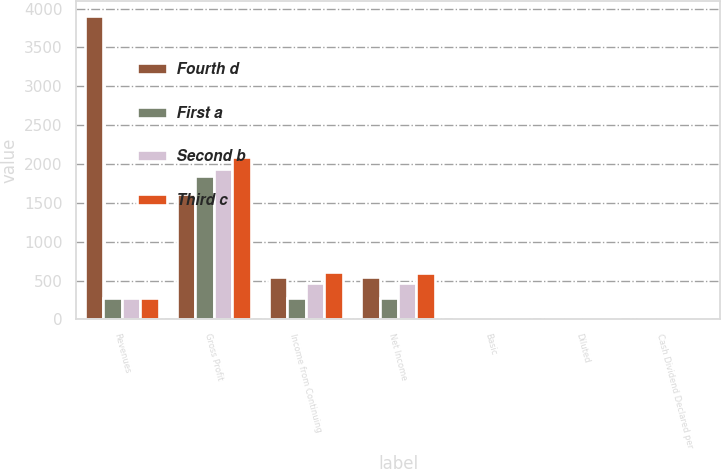Convert chart to OTSL. <chart><loc_0><loc_0><loc_500><loc_500><stacked_bar_chart><ecel><fcel>Revenues<fcel>Gross Profit<fcel>Income from Continuing<fcel>Net Income<fcel>Basic<fcel>Diluted<fcel>Cash Dividend Declared per<nl><fcel>Fourth d<fcel>3903.5<fcel>1620<fcel>543.1<fcel>543.1<fcel>1.38<fcel>1.36<fcel>0.15<nl><fcel>First a<fcel>278.5<fcel>1846.5<fcel>278.5<fcel>278.5<fcel>0.7<fcel>0.69<fcel>0.15<nl><fcel>Second b<fcel>278.5<fcel>1933.6<fcel>469.9<fcel>471.6<fcel>1.17<fcel>1.16<fcel>0.15<nl><fcel>Third c<fcel>278.5<fcel>2091.9<fcel>604<fcel>601.2<fcel>1.51<fcel>1.49<fcel>0.15<nl></chart> 